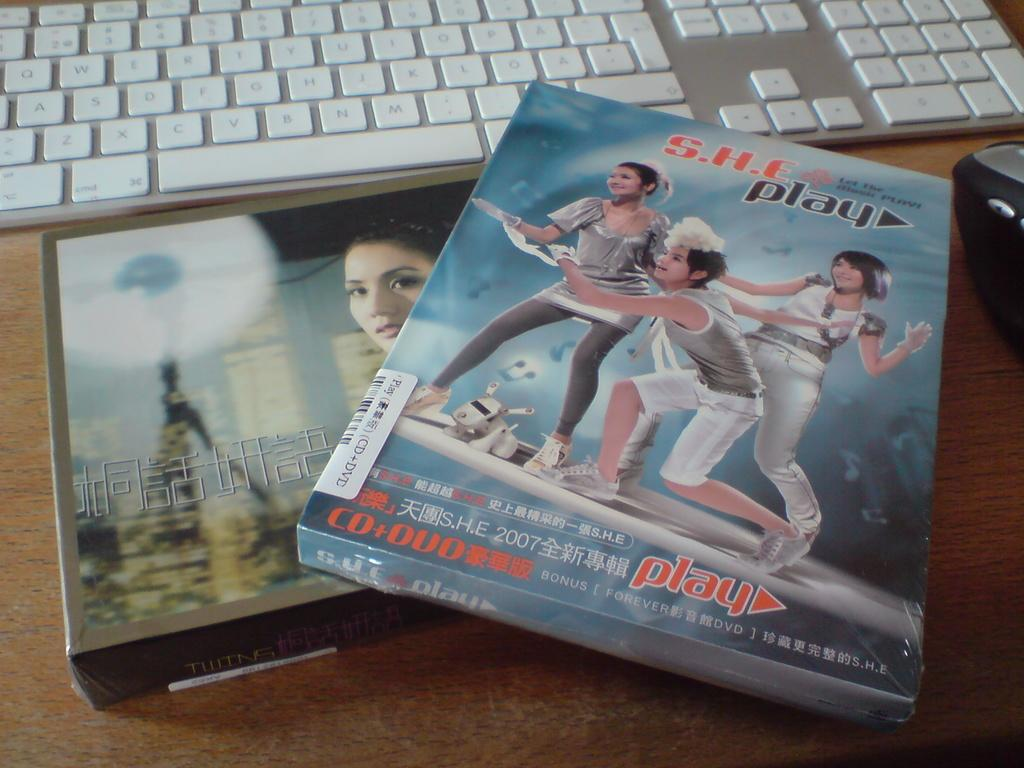How many boxes can be seen in the image? There are two boxes in the image. What other objects are present in the image? There is a keyboard and a mouse in the image. What is the color of the surface on which the objects are placed? The objects are on a brown color surface. How many jewels are placed on the keyboard in the image? There are no jewels present in the image; it only features two boxes, a keyboard, and a mouse. How many babies can be seen playing with the mouse in the image? There are no babies present in the image; it only features two boxes, a keyboard, and a mouse. 